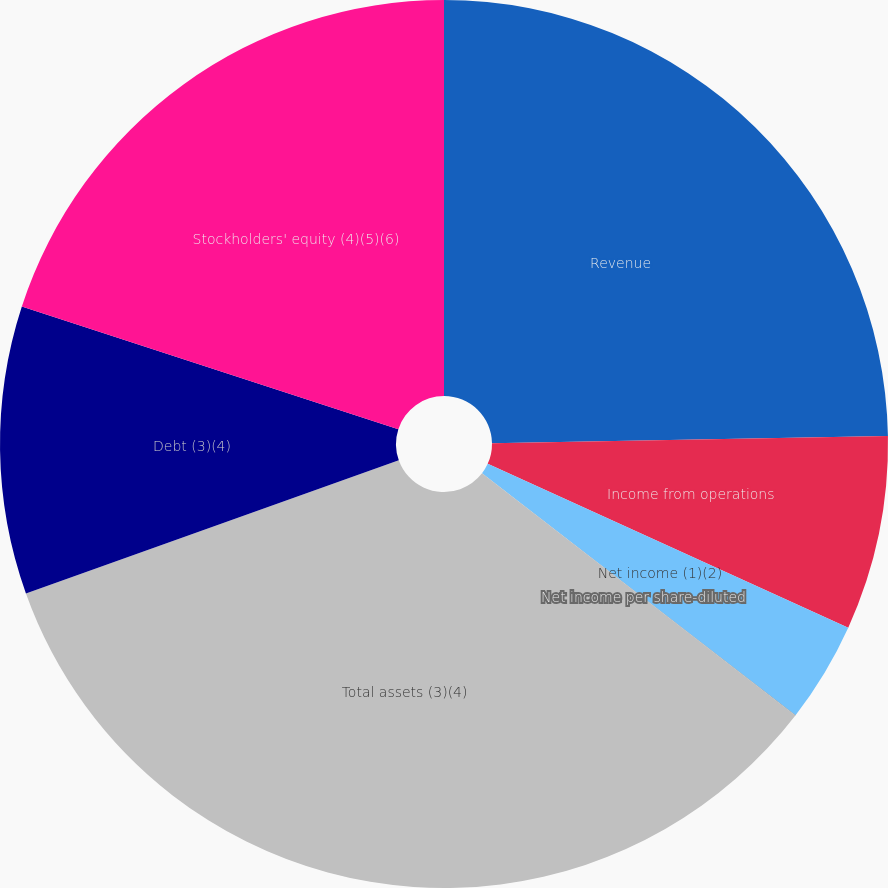Convert chart to OTSL. <chart><loc_0><loc_0><loc_500><loc_500><pie_chart><fcel>Revenue<fcel>Income from operations<fcel>Net income (1)(2)<fcel>Net income per share-diluted<fcel>Total assets (3)(4)<fcel>Debt (3)(4)<fcel>Stockholders' equity (4)(5)(6)<nl><fcel>24.72%<fcel>7.07%<fcel>3.67%<fcel>0.01%<fcel>34.07%<fcel>10.48%<fcel>19.99%<nl></chart> 